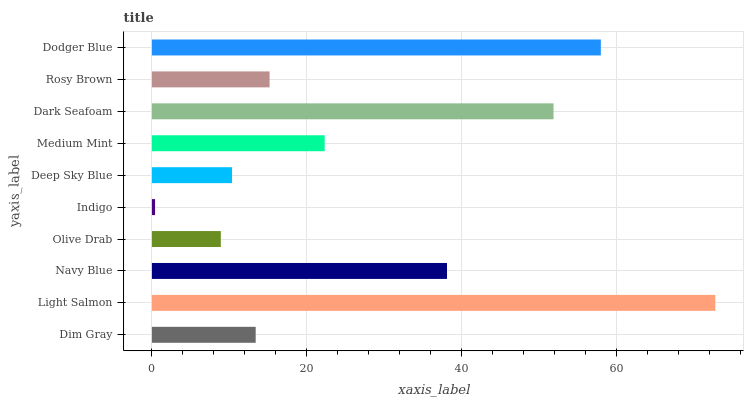Is Indigo the minimum?
Answer yes or no. Yes. Is Light Salmon the maximum?
Answer yes or no. Yes. Is Navy Blue the minimum?
Answer yes or no. No. Is Navy Blue the maximum?
Answer yes or no. No. Is Light Salmon greater than Navy Blue?
Answer yes or no. Yes. Is Navy Blue less than Light Salmon?
Answer yes or no. Yes. Is Navy Blue greater than Light Salmon?
Answer yes or no. No. Is Light Salmon less than Navy Blue?
Answer yes or no. No. Is Medium Mint the high median?
Answer yes or no. Yes. Is Rosy Brown the low median?
Answer yes or no. Yes. Is Rosy Brown the high median?
Answer yes or no. No. Is Deep Sky Blue the low median?
Answer yes or no. No. 